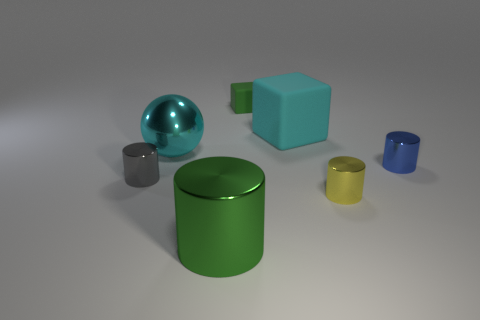Subtract 1 cylinders. How many cylinders are left? 3 Subtract all cyan cylinders. Subtract all green spheres. How many cylinders are left? 4 Add 1 small blue cylinders. How many objects exist? 8 Subtract all blocks. How many objects are left? 5 Subtract all tiny cyan metal cylinders. Subtract all tiny metallic objects. How many objects are left? 4 Add 6 metal cylinders. How many metal cylinders are left? 10 Add 4 big cylinders. How many big cylinders exist? 5 Subtract 0 blue blocks. How many objects are left? 7 